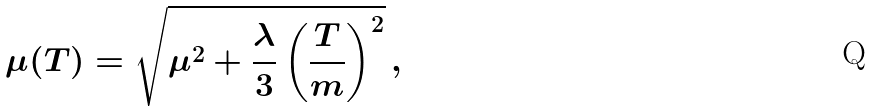Convert formula to latex. <formula><loc_0><loc_0><loc_500><loc_500>\mu ( T ) = \sqrt { \mu ^ { 2 } + \frac { \lambda } { 3 } \left ( \frac { T } { m } \right ) ^ { 2 } } \, ,</formula> 